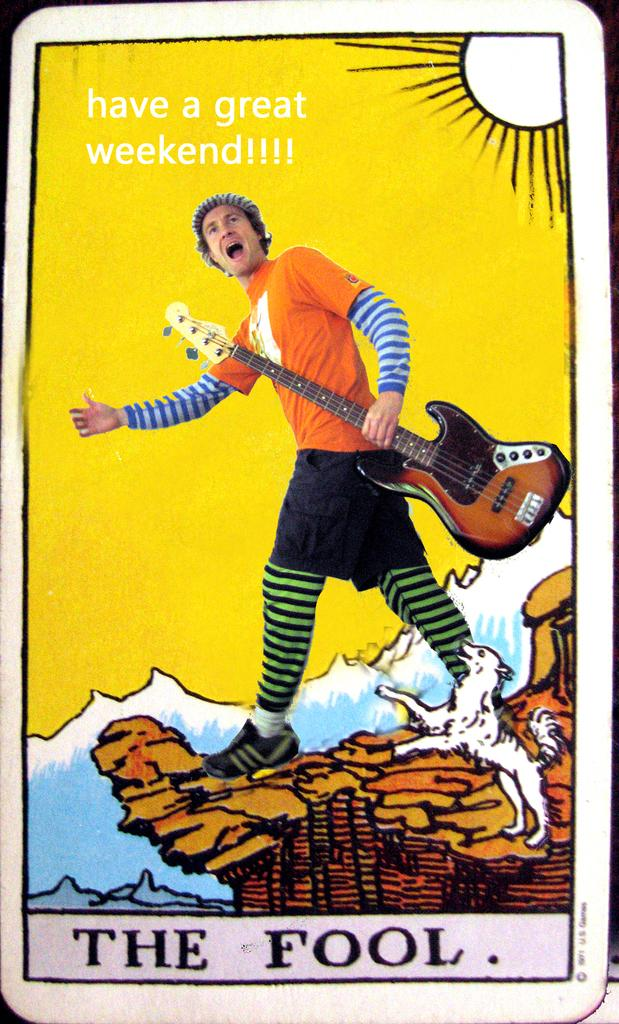What is the person in the image holding? The person is holding a guitar in the image. Where is the person located in the image? The person is on the road in the image. What other living creature is present in the image? There is an animal in the image. What type of natural landscape can be seen in the image? Mountains are visible in the image. What part of the natural environment is visible in the image? The sky is visible in the image. How is the image presented? The image appears to be an animated photo. What type of butter is being used by the person in the image? There is no butter present in the image; the person is holding a guitar. 